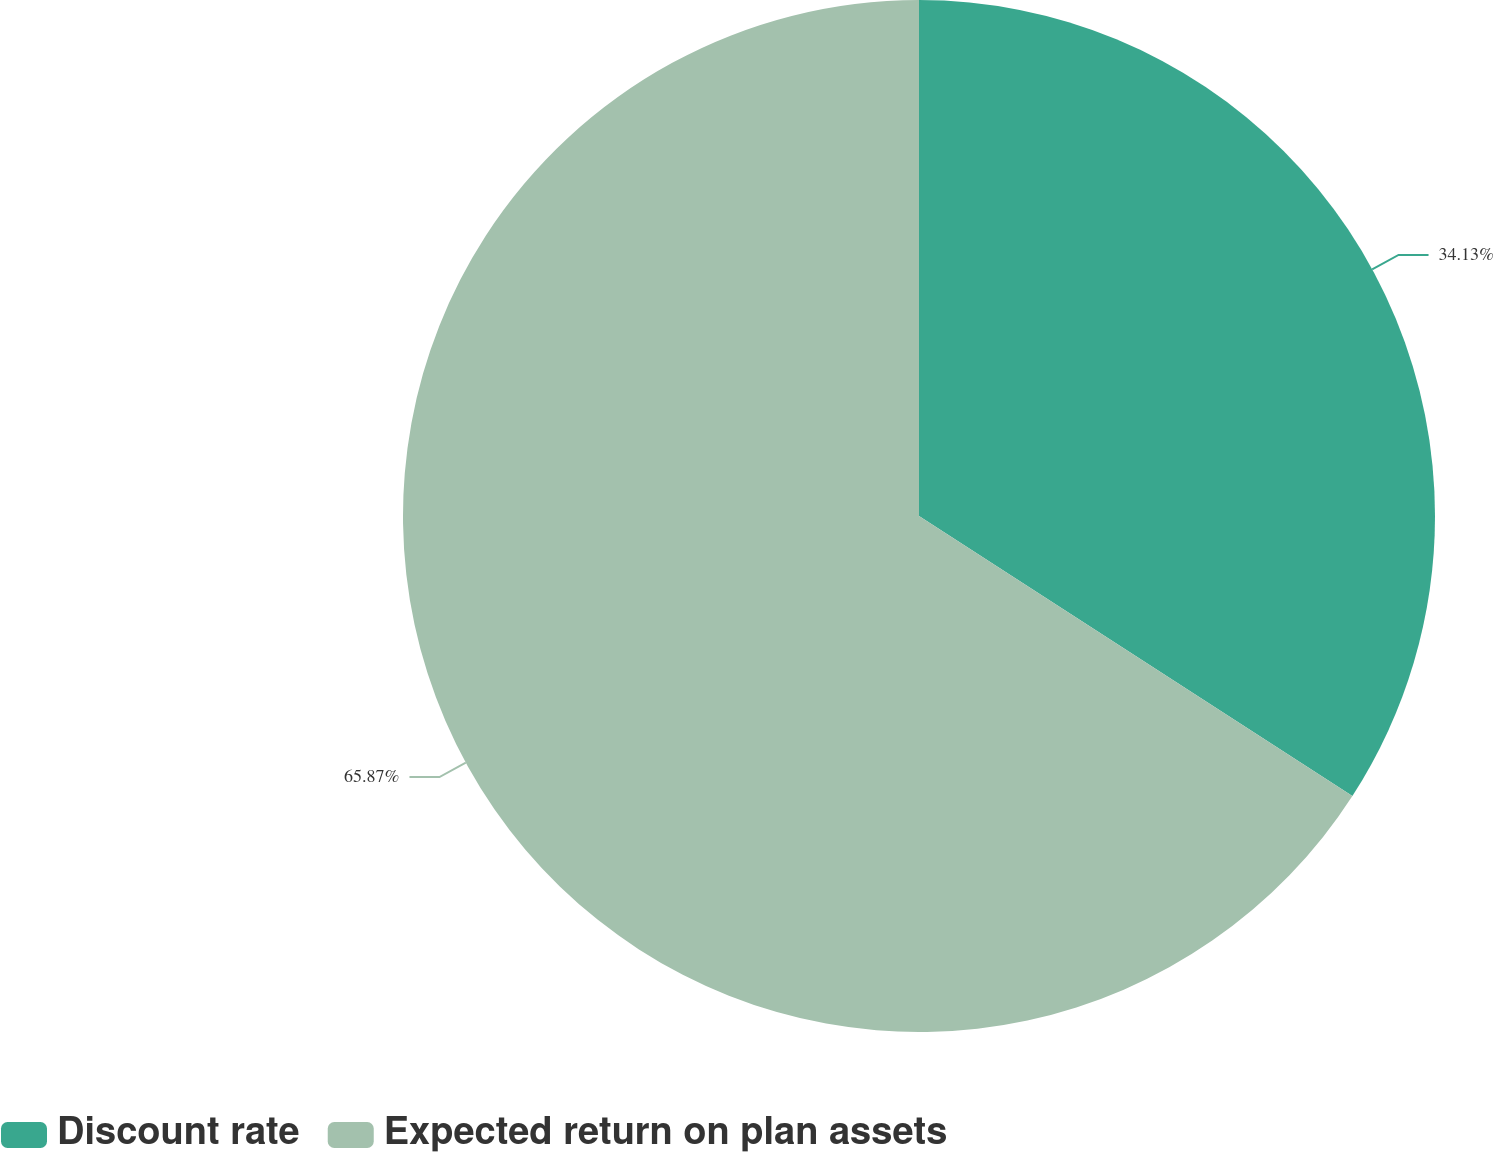<chart> <loc_0><loc_0><loc_500><loc_500><pie_chart><fcel>Discount rate<fcel>Expected return on plan assets<nl><fcel>34.13%<fcel>65.87%<nl></chart> 